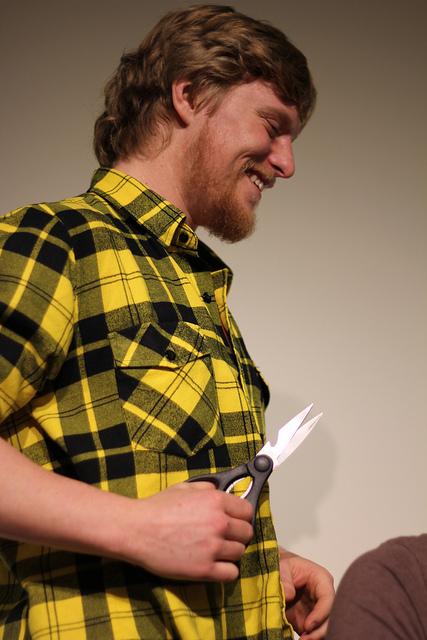Does the person have curly hair?
Keep it brief. No. What color is the person's shirt?
Answer briefly. Yellow and black. What kind of scissors is he holding?
Write a very short answer. Utility. 